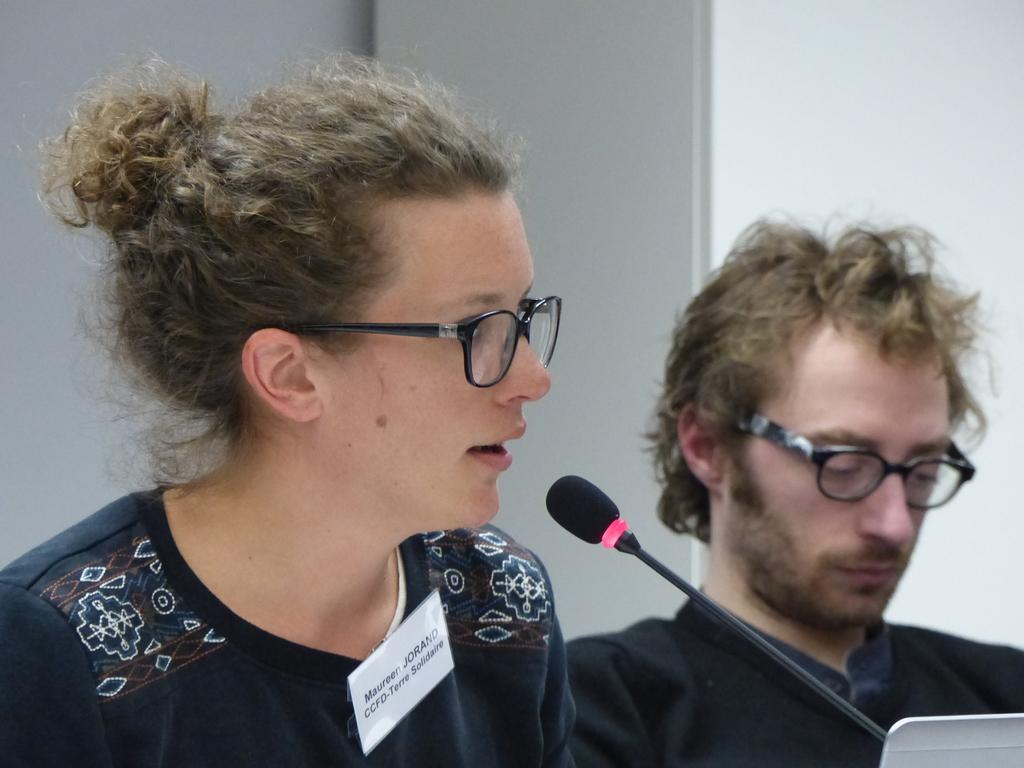Who is the main subject in the image? There is a woman in the image. What is the woman doing in the image? The woman is talking. Can you describe the setting of the image? There is a man in the background of the image, and there is a wall in the background as well. What object is present in the foreground of the image? There is a microphone in the foreground of the image. What type of jar is being used to measure the length of the rod in the image? There is no jar or rod present in the image. 